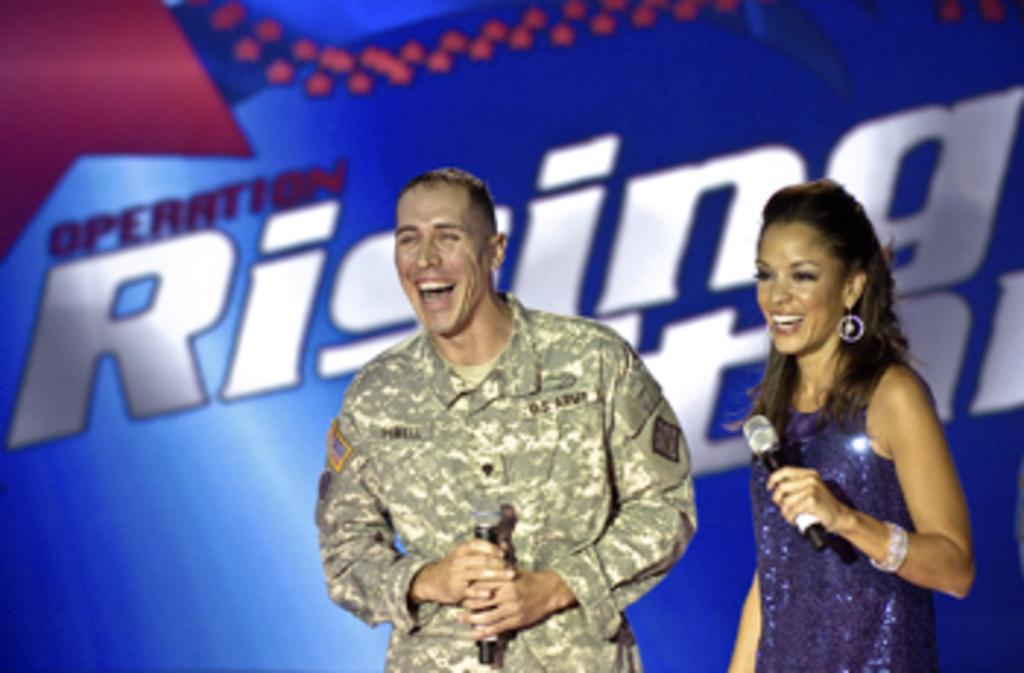Can you describe this image briefly? In this image I can see a man and a woman holding a mic in their hands. They both are laughing. In the background I can see some text. The background is in blue color. 